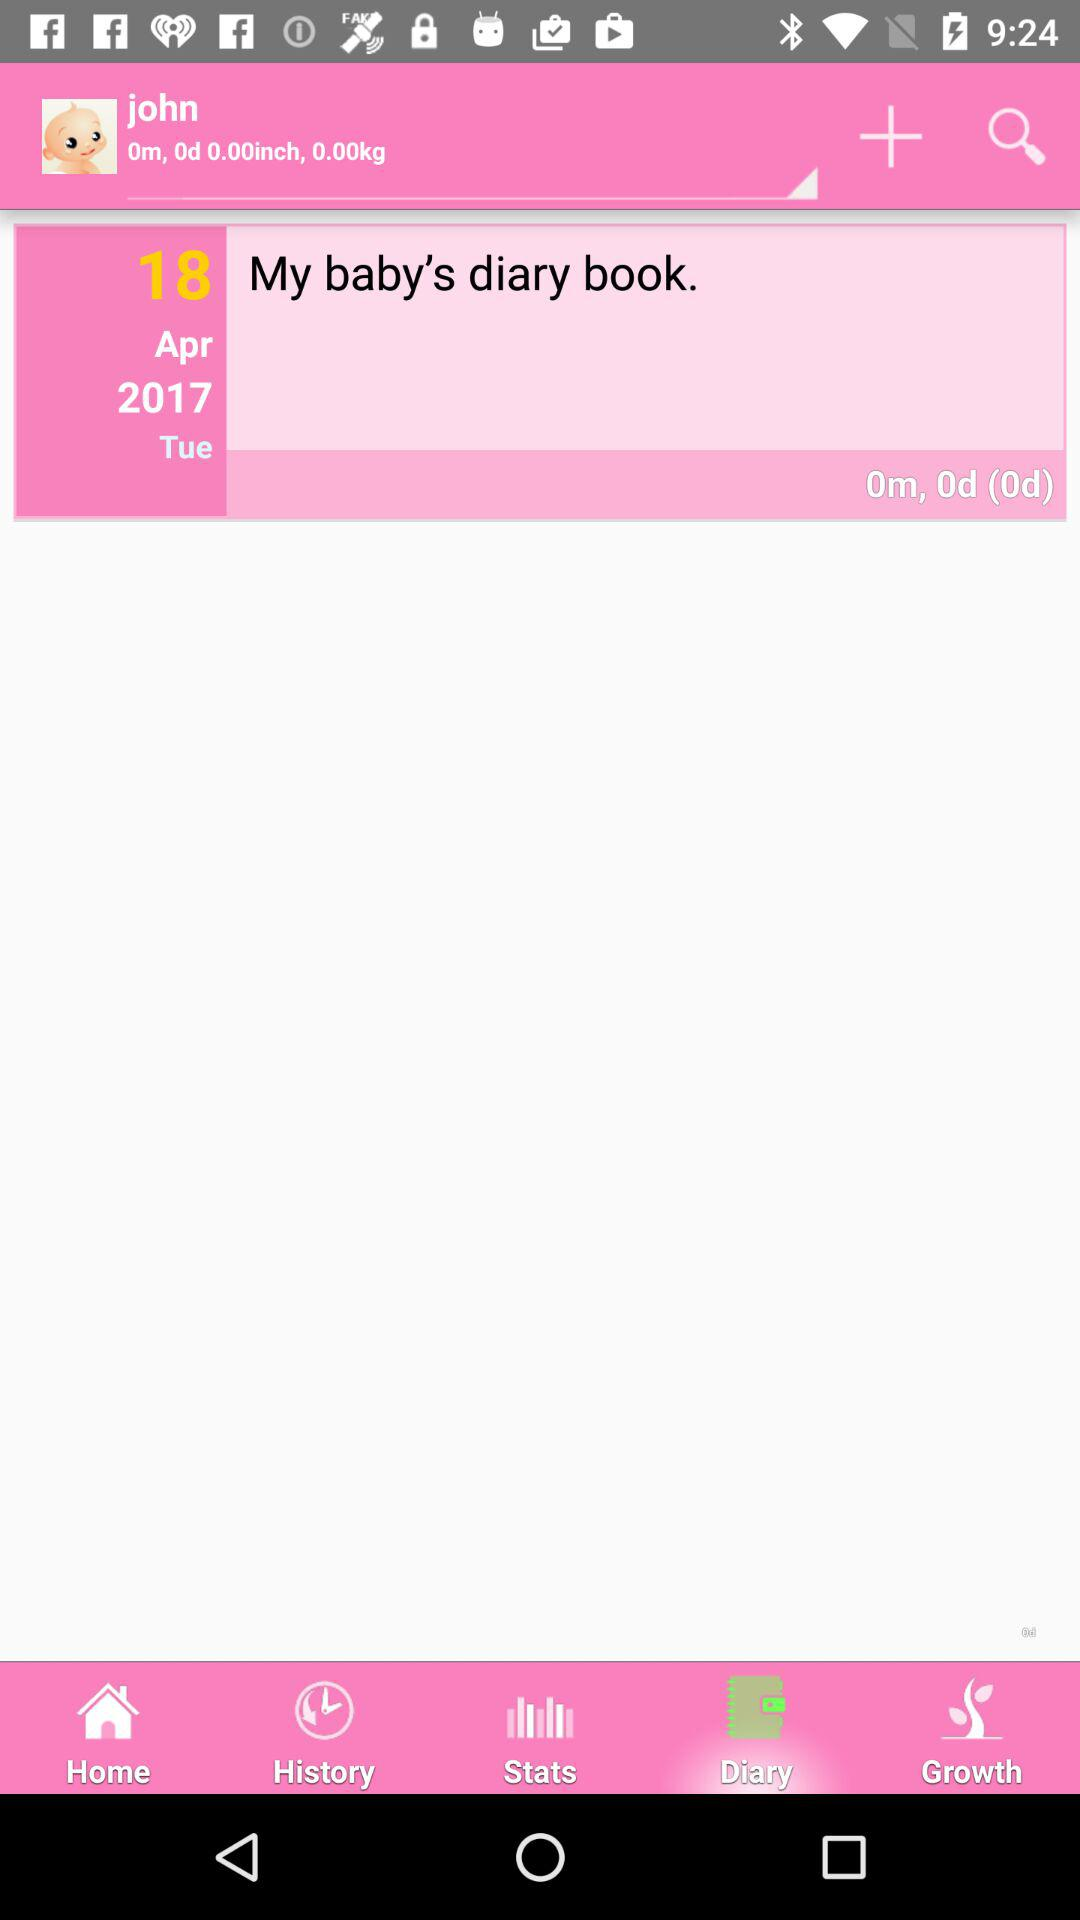What is the username? The username is "john". 